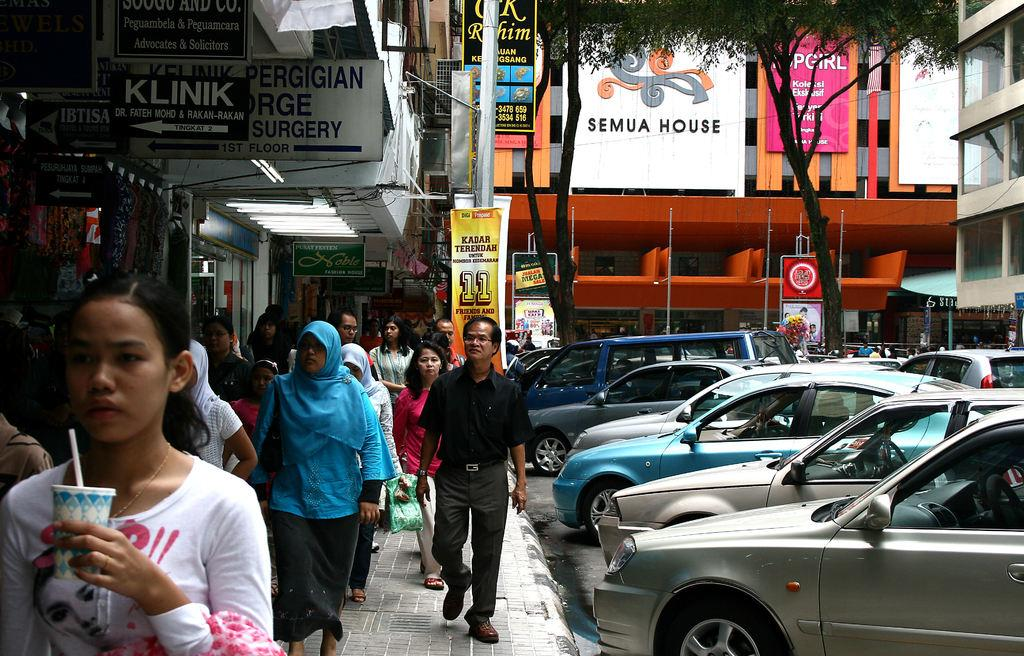<image>
Write a terse but informative summary of the picture. Pedestrians walk down a crowded sidewalk past a surgery center and a store called Klink. 